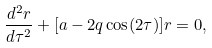Convert formula to latex. <formula><loc_0><loc_0><loc_500><loc_500>\frac { d ^ { 2 } r } { d \tau ^ { 2 } } + [ a - 2 q \cos ( 2 \tau ) ] r = 0 ,</formula> 